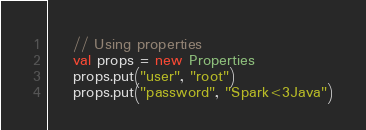Convert code to text. <code><loc_0><loc_0><loc_500><loc_500><_Scala_>    // Using properties
    val props = new Properties
    props.put("user", "root")
    props.put("password", "Spark<3Java")</code> 